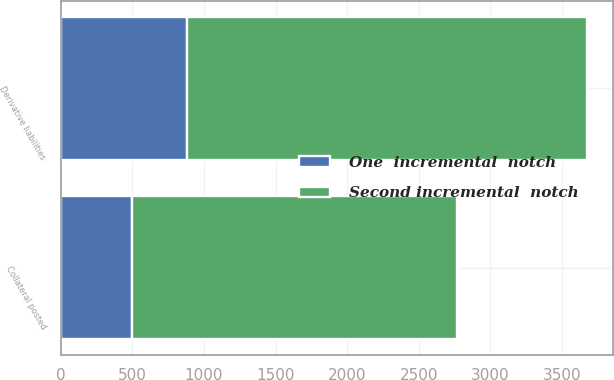<chart> <loc_0><loc_0><loc_500><loc_500><stacked_bar_chart><ecel><fcel>Derivative liabilities<fcel>Collateral posted<nl><fcel>One  incremental  notch<fcel>879<fcel>501<nl><fcel>Second incremental  notch<fcel>2792<fcel>2269<nl></chart> 